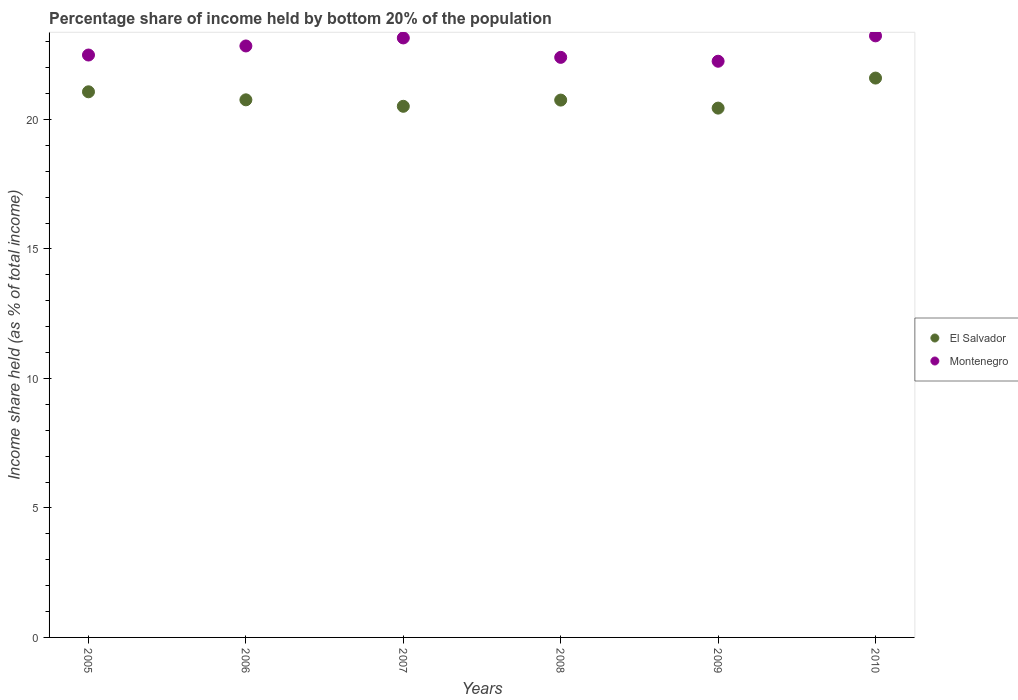How many different coloured dotlines are there?
Offer a very short reply. 2. Is the number of dotlines equal to the number of legend labels?
Give a very brief answer. Yes. What is the share of income held by bottom 20% of the population in El Salvador in 2008?
Your answer should be compact. 20.75. Across all years, what is the maximum share of income held by bottom 20% of the population in Montenegro?
Make the answer very short. 23.23. Across all years, what is the minimum share of income held by bottom 20% of the population in El Salvador?
Keep it short and to the point. 20.44. What is the total share of income held by bottom 20% of the population in El Salvador in the graph?
Provide a succinct answer. 125.13. What is the difference between the share of income held by bottom 20% of the population in Montenegro in 2009 and that in 2010?
Provide a succinct answer. -0.98. What is the difference between the share of income held by bottom 20% of the population in Montenegro in 2007 and the share of income held by bottom 20% of the population in El Salvador in 2009?
Your answer should be compact. 2.71. What is the average share of income held by bottom 20% of the population in Montenegro per year?
Offer a terse response. 22.73. In the year 2009, what is the difference between the share of income held by bottom 20% of the population in El Salvador and share of income held by bottom 20% of the population in Montenegro?
Your answer should be compact. -1.81. What is the ratio of the share of income held by bottom 20% of the population in Montenegro in 2005 to that in 2010?
Your answer should be compact. 0.97. Is the share of income held by bottom 20% of the population in Montenegro in 2005 less than that in 2008?
Offer a very short reply. No. Is the difference between the share of income held by bottom 20% of the population in El Salvador in 2005 and 2010 greater than the difference between the share of income held by bottom 20% of the population in Montenegro in 2005 and 2010?
Provide a succinct answer. Yes. What is the difference between the highest and the second highest share of income held by bottom 20% of the population in Montenegro?
Your response must be concise. 0.08. What is the difference between the highest and the lowest share of income held by bottom 20% of the population in El Salvador?
Offer a very short reply. 1.16. In how many years, is the share of income held by bottom 20% of the population in El Salvador greater than the average share of income held by bottom 20% of the population in El Salvador taken over all years?
Make the answer very short. 2. Is the sum of the share of income held by bottom 20% of the population in Montenegro in 2005 and 2010 greater than the maximum share of income held by bottom 20% of the population in El Salvador across all years?
Make the answer very short. Yes. Is the share of income held by bottom 20% of the population in Montenegro strictly greater than the share of income held by bottom 20% of the population in El Salvador over the years?
Offer a very short reply. Yes. How many legend labels are there?
Your answer should be compact. 2. How are the legend labels stacked?
Keep it short and to the point. Vertical. What is the title of the graph?
Your response must be concise. Percentage share of income held by bottom 20% of the population. What is the label or title of the Y-axis?
Ensure brevity in your answer.  Income share held (as % of total income). What is the Income share held (as % of total income) of El Salvador in 2005?
Offer a terse response. 21.07. What is the Income share held (as % of total income) of Montenegro in 2005?
Offer a terse response. 22.49. What is the Income share held (as % of total income) in El Salvador in 2006?
Provide a succinct answer. 20.76. What is the Income share held (as % of total income) of Montenegro in 2006?
Offer a very short reply. 22.84. What is the Income share held (as % of total income) in El Salvador in 2007?
Ensure brevity in your answer.  20.51. What is the Income share held (as % of total income) in Montenegro in 2007?
Make the answer very short. 23.15. What is the Income share held (as % of total income) of El Salvador in 2008?
Your response must be concise. 20.75. What is the Income share held (as % of total income) of Montenegro in 2008?
Keep it short and to the point. 22.4. What is the Income share held (as % of total income) of El Salvador in 2009?
Offer a very short reply. 20.44. What is the Income share held (as % of total income) in Montenegro in 2009?
Give a very brief answer. 22.25. What is the Income share held (as % of total income) in El Salvador in 2010?
Provide a short and direct response. 21.6. What is the Income share held (as % of total income) in Montenegro in 2010?
Keep it short and to the point. 23.23. Across all years, what is the maximum Income share held (as % of total income) of El Salvador?
Your answer should be compact. 21.6. Across all years, what is the maximum Income share held (as % of total income) of Montenegro?
Give a very brief answer. 23.23. Across all years, what is the minimum Income share held (as % of total income) in El Salvador?
Make the answer very short. 20.44. Across all years, what is the minimum Income share held (as % of total income) of Montenegro?
Offer a very short reply. 22.25. What is the total Income share held (as % of total income) of El Salvador in the graph?
Give a very brief answer. 125.13. What is the total Income share held (as % of total income) of Montenegro in the graph?
Make the answer very short. 136.36. What is the difference between the Income share held (as % of total income) in El Salvador in 2005 and that in 2006?
Give a very brief answer. 0.31. What is the difference between the Income share held (as % of total income) of Montenegro in 2005 and that in 2006?
Ensure brevity in your answer.  -0.35. What is the difference between the Income share held (as % of total income) in El Salvador in 2005 and that in 2007?
Make the answer very short. 0.56. What is the difference between the Income share held (as % of total income) in Montenegro in 2005 and that in 2007?
Make the answer very short. -0.66. What is the difference between the Income share held (as % of total income) of El Salvador in 2005 and that in 2008?
Your response must be concise. 0.32. What is the difference between the Income share held (as % of total income) of Montenegro in 2005 and that in 2008?
Give a very brief answer. 0.09. What is the difference between the Income share held (as % of total income) in El Salvador in 2005 and that in 2009?
Provide a succinct answer. 0.63. What is the difference between the Income share held (as % of total income) in Montenegro in 2005 and that in 2009?
Give a very brief answer. 0.24. What is the difference between the Income share held (as % of total income) in El Salvador in 2005 and that in 2010?
Offer a terse response. -0.53. What is the difference between the Income share held (as % of total income) in Montenegro in 2005 and that in 2010?
Give a very brief answer. -0.74. What is the difference between the Income share held (as % of total income) of Montenegro in 2006 and that in 2007?
Offer a terse response. -0.31. What is the difference between the Income share held (as % of total income) in Montenegro in 2006 and that in 2008?
Your answer should be very brief. 0.44. What is the difference between the Income share held (as % of total income) of El Salvador in 2006 and that in 2009?
Give a very brief answer. 0.32. What is the difference between the Income share held (as % of total income) of Montenegro in 2006 and that in 2009?
Provide a succinct answer. 0.59. What is the difference between the Income share held (as % of total income) in El Salvador in 2006 and that in 2010?
Your response must be concise. -0.84. What is the difference between the Income share held (as % of total income) in Montenegro in 2006 and that in 2010?
Provide a succinct answer. -0.39. What is the difference between the Income share held (as % of total income) in El Salvador in 2007 and that in 2008?
Provide a short and direct response. -0.24. What is the difference between the Income share held (as % of total income) of El Salvador in 2007 and that in 2009?
Make the answer very short. 0.07. What is the difference between the Income share held (as % of total income) of Montenegro in 2007 and that in 2009?
Ensure brevity in your answer.  0.9. What is the difference between the Income share held (as % of total income) of El Salvador in 2007 and that in 2010?
Make the answer very short. -1.09. What is the difference between the Income share held (as % of total income) in Montenegro in 2007 and that in 2010?
Provide a succinct answer. -0.08. What is the difference between the Income share held (as % of total income) of El Salvador in 2008 and that in 2009?
Give a very brief answer. 0.31. What is the difference between the Income share held (as % of total income) of Montenegro in 2008 and that in 2009?
Make the answer very short. 0.15. What is the difference between the Income share held (as % of total income) of El Salvador in 2008 and that in 2010?
Provide a short and direct response. -0.85. What is the difference between the Income share held (as % of total income) of Montenegro in 2008 and that in 2010?
Offer a terse response. -0.83. What is the difference between the Income share held (as % of total income) of El Salvador in 2009 and that in 2010?
Give a very brief answer. -1.16. What is the difference between the Income share held (as % of total income) of Montenegro in 2009 and that in 2010?
Make the answer very short. -0.98. What is the difference between the Income share held (as % of total income) in El Salvador in 2005 and the Income share held (as % of total income) in Montenegro in 2006?
Your answer should be very brief. -1.77. What is the difference between the Income share held (as % of total income) of El Salvador in 2005 and the Income share held (as % of total income) of Montenegro in 2007?
Your answer should be compact. -2.08. What is the difference between the Income share held (as % of total income) of El Salvador in 2005 and the Income share held (as % of total income) of Montenegro in 2008?
Your answer should be compact. -1.33. What is the difference between the Income share held (as % of total income) in El Salvador in 2005 and the Income share held (as % of total income) in Montenegro in 2009?
Provide a succinct answer. -1.18. What is the difference between the Income share held (as % of total income) in El Salvador in 2005 and the Income share held (as % of total income) in Montenegro in 2010?
Your answer should be very brief. -2.16. What is the difference between the Income share held (as % of total income) of El Salvador in 2006 and the Income share held (as % of total income) of Montenegro in 2007?
Offer a terse response. -2.39. What is the difference between the Income share held (as % of total income) of El Salvador in 2006 and the Income share held (as % of total income) of Montenegro in 2008?
Your response must be concise. -1.64. What is the difference between the Income share held (as % of total income) in El Salvador in 2006 and the Income share held (as % of total income) in Montenegro in 2009?
Give a very brief answer. -1.49. What is the difference between the Income share held (as % of total income) in El Salvador in 2006 and the Income share held (as % of total income) in Montenegro in 2010?
Ensure brevity in your answer.  -2.47. What is the difference between the Income share held (as % of total income) in El Salvador in 2007 and the Income share held (as % of total income) in Montenegro in 2008?
Give a very brief answer. -1.89. What is the difference between the Income share held (as % of total income) of El Salvador in 2007 and the Income share held (as % of total income) of Montenegro in 2009?
Offer a terse response. -1.74. What is the difference between the Income share held (as % of total income) in El Salvador in 2007 and the Income share held (as % of total income) in Montenegro in 2010?
Your response must be concise. -2.72. What is the difference between the Income share held (as % of total income) in El Salvador in 2008 and the Income share held (as % of total income) in Montenegro in 2009?
Your response must be concise. -1.5. What is the difference between the Income share held (as % of total income) in El Salvador in 2008 and the Income share held (as % of total income) in Montenegro in 2010?
Make the answer very short. -2.48. What is the difference between the Income share held (as % of total income) in El Salvador in 2009 and the Income share held (as % of total income) in Montenegro in 2010?
Provide a short and direct response. -2.79. What is the average Income share held (as % of total income) of El Salvador per year?
Your answer should be compact. 20.86. What is the average Income share held (as % of total income) in Montenegro per year?
Your answer should be very brief. 22.73. In the year 2005, what is the difference between the Income share held (as % of total income) in El Salvador and Income share held (as % of total income) in Montenegro?
Your answer should be compact. -1.42. In the year 2006, what is the difference between the Income share held (as % of total income) in El Salvador and Income share held (as % of total income) in Montenegro?
Make the answer very short. -2.08. In the year 2007, what is the difference between the Income share held (as % of total income) in El Salvador and Income share held (as % of total income) in Montenegro?
Ensure brevity in your answer.  -2.64. In the year 2008, what is the difference between the Income share held (as % of total income) in El Salvador and Income share held (as % of total income) in Montenegro?
Your answer should be compact. -1.65. In the year 2009, what is the difference between the Income share held (as % of total income) of El Salvador and Income share held (as % of total income) of Montenegro?
Offer a very short reply. -1.81. In the year 2010, what is the difference between the Income share held (as % of total income) in El Salvador and Income share held (as % of total income) in Montenegro?
Offer a terse response. -1.63. What is the ratio of the Income share held (as % of total income) of El Salvador in 2005 to that in 2006?
Give a very brief answer. 1.01. What is the ratio of the Income share held (as % of total income) of Montenegro in 2005 to that in 2006?
Give a very brief answer. 0.98. What is the ratio of the Income share held (as % of total income) of El Salvador in 2005 to that in 2007?
Offer a very short reply. 1.03. What is the ratio of the Income share held (as % of total income) of Montenegro in 2005 to that in 2007?
Provide a succinct answer. 0.97. What is the ratio of the Income share held (as % of total income) of El Salvador in 2005 to that in 2008?
Keep it short and to the point. 1.02. What is the ratio of the Income share held (as % of total income) in El Salvador in 2005 to that in 2009?
Keep it short and to the point. 1.03. What is the ratio of the Income share held (as % of total income) of Montenegro in 2005 to that in 2009?
Keep it short and to the point. 1.01. What is the ratio of the Income share held (as % of total income) in El Salvador in 2005 to that in 2010?
Give a very brief answer. 0.98. What is the ratio of the Income share held (as % of total income) in Montenegro in 2005 to that in 2010?
Provide a succinct answer. 0.97. What is the ratio of the Income share held (as % of total income) of El Salvador in 2006 to that in 2007?
Ensure brevity in your answer.  1.01. What is the ratio of the Income share held (as % of total income) of Montenegro in 2006 to that in 2007?
Offer a terse response. 0.99. What is the ratio of the Income share held (as % of total income) in El Salvador in 2006 to that in 2008?
Your answer should be very brief. 1. What is the ratio of the Income share held (as % of total income) of Montenegro in 2006 to that in 2008?
Offer a terse response. 1.02. What is the ratio of the Income share held (as % of total income) of El Salvador in 2006 to that in 2009?
Your response must be concise. 1.02. What is the ratio of the Income share held (as % of total income) of Montenegro in 2006 to that in 2009?
Offer a very short reply. 1.03. What is the ratio of the Income share held (as % of total income) in El Salvador in 2006 to that in 2010?
Offer a very short reply. 0.96. What is the ratio of the Income share held (as % of total income) of Montenegro in 2006 to that in 2010?
Your answer should be compact. 0.98. What is the ratio of the Income share held (as % of total income) in El Salvador in 2007 to that in 2008?
Provide a succinct answer. 0.99. What is the ratio of the Income share held (as % of total income) of Montenegro in 2007 to that in 2008?
Your response must be concise. 1.03. What is the ratio of the Income share held (as % of total income) in Montenegro in 2007 to that in 2009?
Your answer should be very brief. 1.04. What is the ratio of the Income share held (as % of total income) of El Salvador in 2007 to that in 2010?
Offer a terse response. 0.95. What is the ratio of the Income share held (as % of total income) in El Salvador in 2008 to that in 2009?
Provide a succinct answer. 1.02. What is the ratio of the Income share held (as % of total income) in El Salvador in 2008 to that in 2010?
Ensure brevity in your answer.  0.96. What is the ratio of the Income share held (as % of total income) of Montenegro in 2008 to that in 2010?
Keep it short and to the point. 0.96. What is the ratio of the Income share held (as % of total income) of El Salvador in 2009 to that in 2010?
Provide a succinct answer. 0.95. What is the ratio of the Income share held (as % of total income) in Montenegro in 2009 to that in 2010?
Make the answer very short. 0.96. What is the difference between the highest and the second highest Income share held (as % of total income) in El Salvador?
Offer a terse response. 0.53. What is the difference between the highest and the lowest Income share held (as % of total income) in El Salvador?
Offer a very short reply. 1.16. 